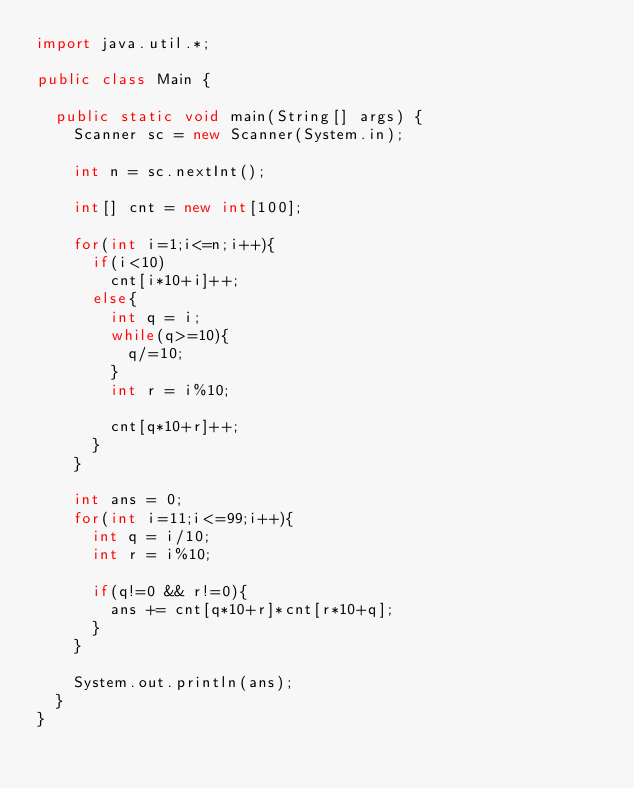<code> <loc_0><loc_0><loc_500><loc_500><_Java_>import java.util.*;
 
public class Main {
	
	public static void main(String[] args) {
		Scanner sc = new Scanner(System.in);
		
		int n = sc.nextInt();
		
		int[] cnt = new int[100];
		
		for(int i=1;i<=n;i++){
			if(i<10)
				cnt[i*10+i]++;
			else{
				int q = i;
				while(q>=10){
					q/=10;
				}
				int r = i%10;
				
				cnt[q*10+r]++;
			}
		}
		
		int ans = 0;
		for(int i=11;i<=99;i++){
			int q = i/10;
			int r = i%10;
			
			if(q!=0 && r!=0){
				ans += cnt[q*10+r]*cnt[r*10+q];
			}
		}
		
		System.out.println(ans);
	}
}</code> 